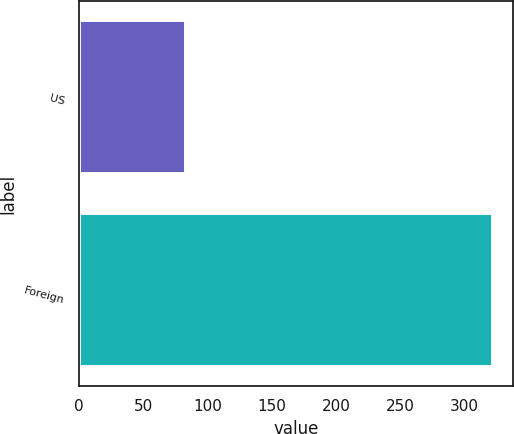Convert chart to OTSL. <chart><loc_0><loc_0><loc_500><loc_500><bar_chart><fcel>US<fcel>Foreign<nl><fcel>83<fcel>322<nl></chart> 